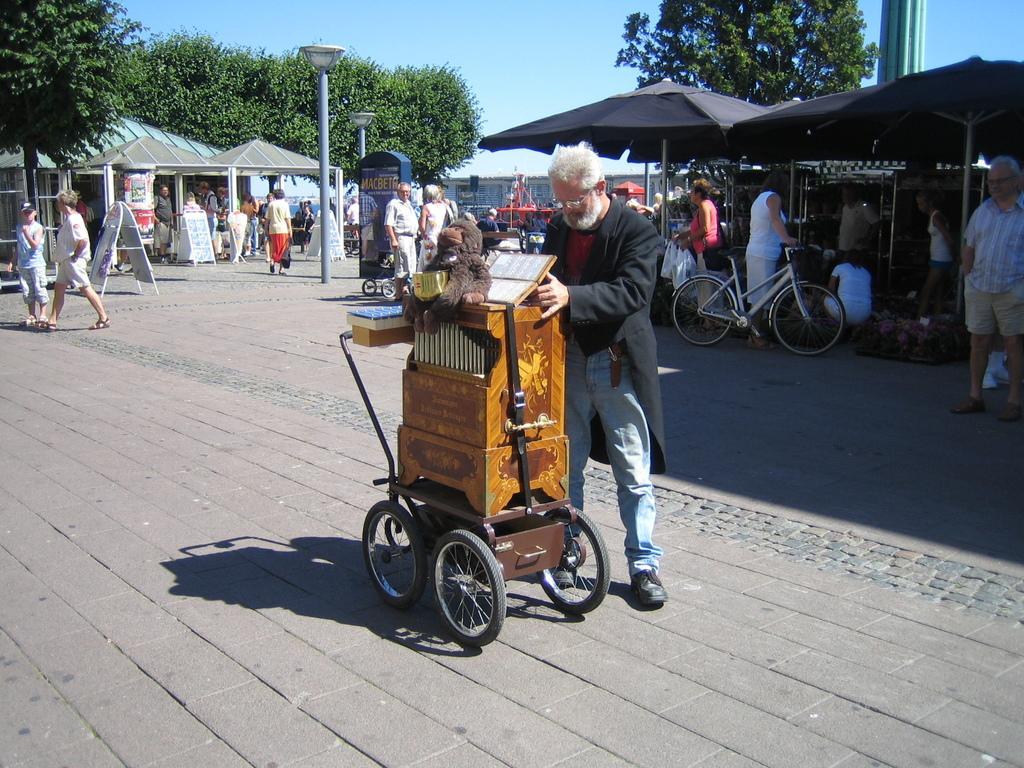Describe this image in one or two sentences. In this picture I can see there is a man holding a wooden object and in the backdrop I can see there are some people and there are poles, trees and the sky is clear. 